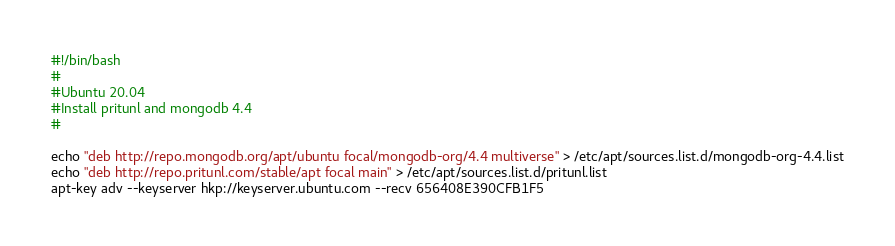<code> <loc_0><loc_0><loc_500><loc_500><_Bash_>#!/bin/bash
#
#Ubuntu 20.04
#Install pritunl and mongodb 4.4
#

echo "deb http://repo.mongodb.org/apt/ubuntu focal/mongodb-org/4.4 multiverse" > /etc/apt/sources.list.d/mongodb-org-4.4.list
echo "deb http://repo.pritunl.com/stable/apt focal main" > /etc/apt/sources.list.d/pritunl.list
apt-key adv --keyserver hkp://keyserver.ubuntu.com --recv 656408E390CFB1F5</code> 